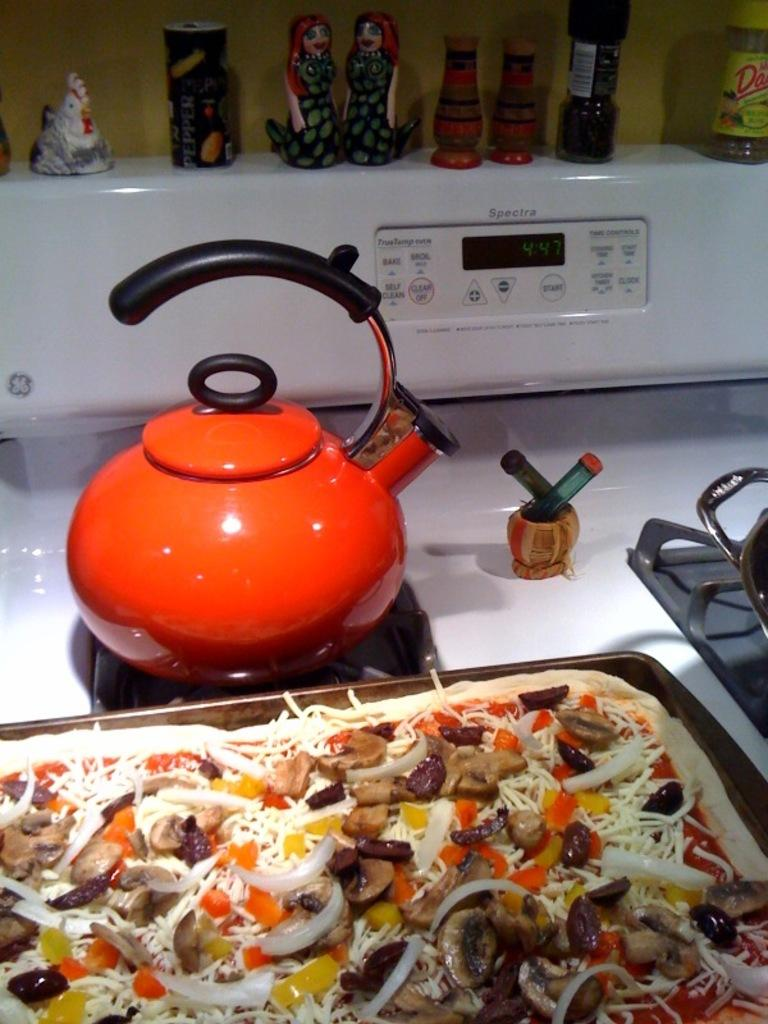What is the main object in the image? There is a teapot in the image. What else can be seen on the stove? There is food on a tray in the image. Where are the teapot and food located? The teapot and food are on a stove. What can be seen in the background of the image? There are objects visible in the background of the image, and there is a wall in the background. What type of seed is being used to grow a plant in the image? There is no seed or plant visible in the image; it features a teapot, food on a tray, and a stove. What type of locket is hanging from the wall in the image? There is no locket present in the image; it features a teapot, food on a tray, and a stove with a wall in the background. 